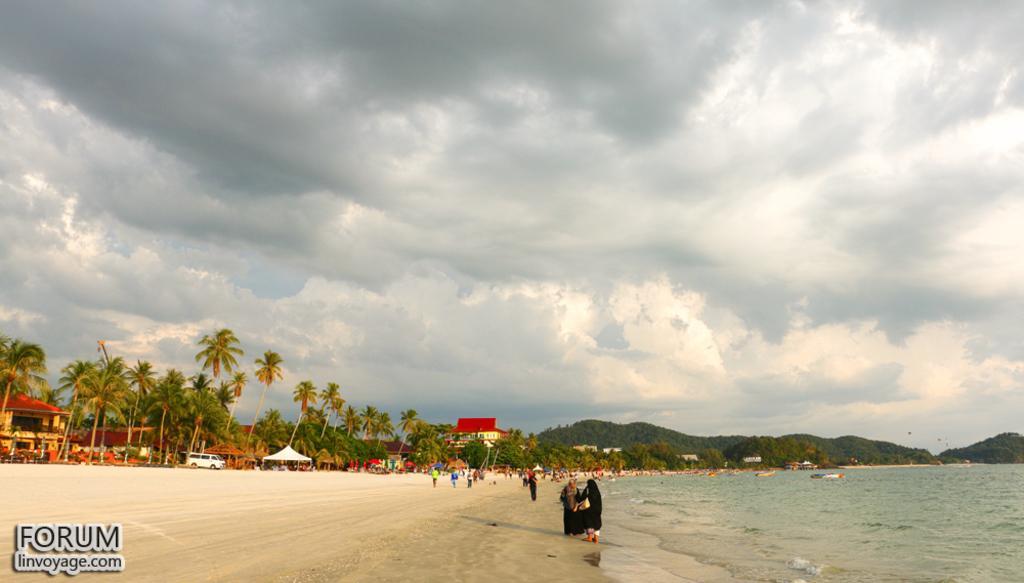Please provide a concise description of this image. This is the picture of a beach. At the back there are mountains. On the left side of the image there are buildings and trees and tents and there is a vehicle and there are group of people. At the top there is sky and there are clouds. At the bottom there is sand and water. At the bottom left there is text. 